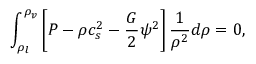<formula> <loc_0><loc_0><loc_500><loc_500>\int _ { \rho _ { l } } ^ { \rho _ { v } } \left [ P - \rho c _ { s } ^ { 2 } - \frac { G } { 2 } \psi ^ { 2 } \right ] \frac { 1 } { \rho ^ { 2 } } d \rho = 0 ,</formula> 